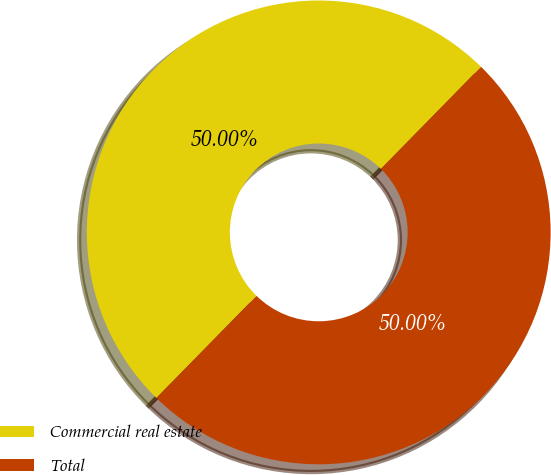Convert chart. <chart><loc_0><loc_0><loc_500><loc_500><pie_chart><fcel>Commercial real estate<fcel>Total<nl><fcel>50.0%<fcel>50.0%<nl></chart> 